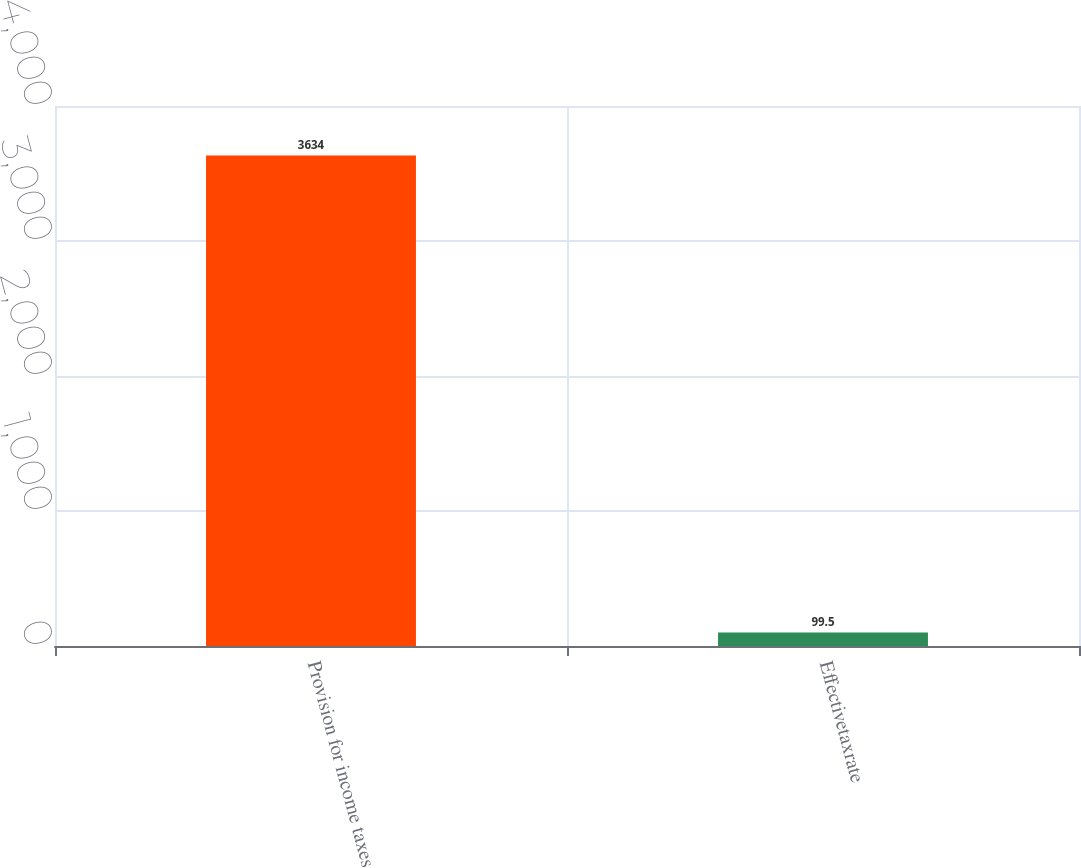<chart> <loc_0><loc_0><loc_500><loc_500><bar_chart><fcel>Provision for income taxes<fcel>Effectivetaxrate<nl><fcel>3634<fcel>99.5<nl></chart> 